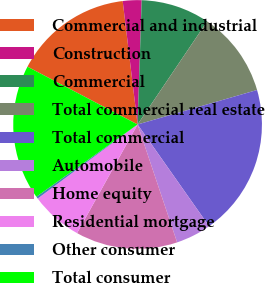Convert chart to OTSL. <chart><loc_0><loc_0><loc_500><loc_500><pie_chart><fcel>Commercial and industrial<fcel>Construction<fcel>Commercial<fcel>Total commercial real estate<fcel>Total commercial<fcel>Automobile<fcel>Home equity<fcel>Residential mortgage<fcel>Other consumer<fcel>Total consumer<nl><fcel>15.4%<fcel>2.44%<fcel>8.92%<fcel>11.08%<fcel>19.72%<fcel>4.6%<fcel>13.24%<fcel>6.76%<fcel>0.28%<fcel>17.56%<nl></chart> 